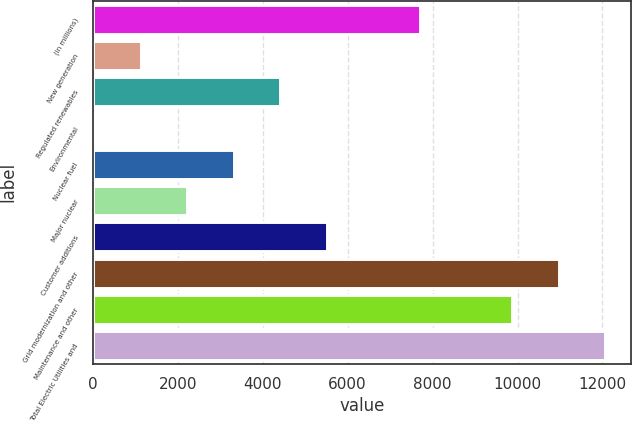<chart> <loc_0><loc_0><loc_500><loc_500><bar_chart><fcel>(in millions)<fcel>New generation<fcel>Regulated renewables<fcel>Environmental<fcel>Nuclear fuel<fcel>Major nuclear<fcel>Customer additions<fcel>Grid modernization and other<fcel>Maintenance and other<fcel>Total Electric Utilities and<nl><fcel>7693<fcel>1129<fcel>4411<fcel>35<fcel>3317<fcel>2223<fcel>5505<fcel>10975<fcel>9881<fcel>12069<nl></chart> 